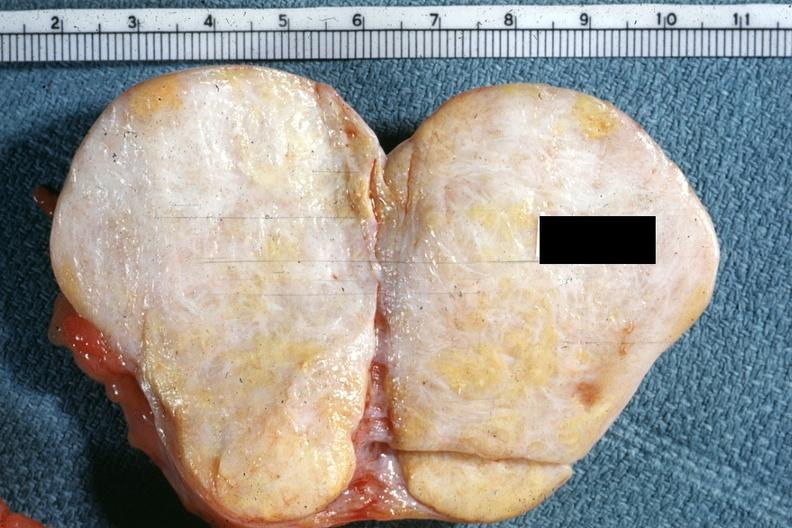s cystadenocarcinoma malignancy present?
Answer the question using a single word or phrase. No 